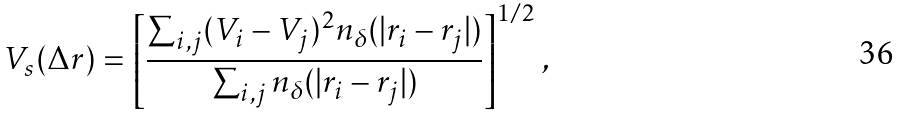<formula> <loc_0><loc_0><loc_500><loc_500>V _ { s } ( \Delta r ) = \left [ \frac { \sum _ { i , j } ( V _ { i } - V _ { j } ) ^ { 2 } n _ { \delta } ( | r _ { i } - r _ { j } | ) } { \sum _ { i , j } n _ { \delta } ( | r _ { i } - r _ { j } | ) } \right ] ^ { 1 / 2 } \, ,</formula> 